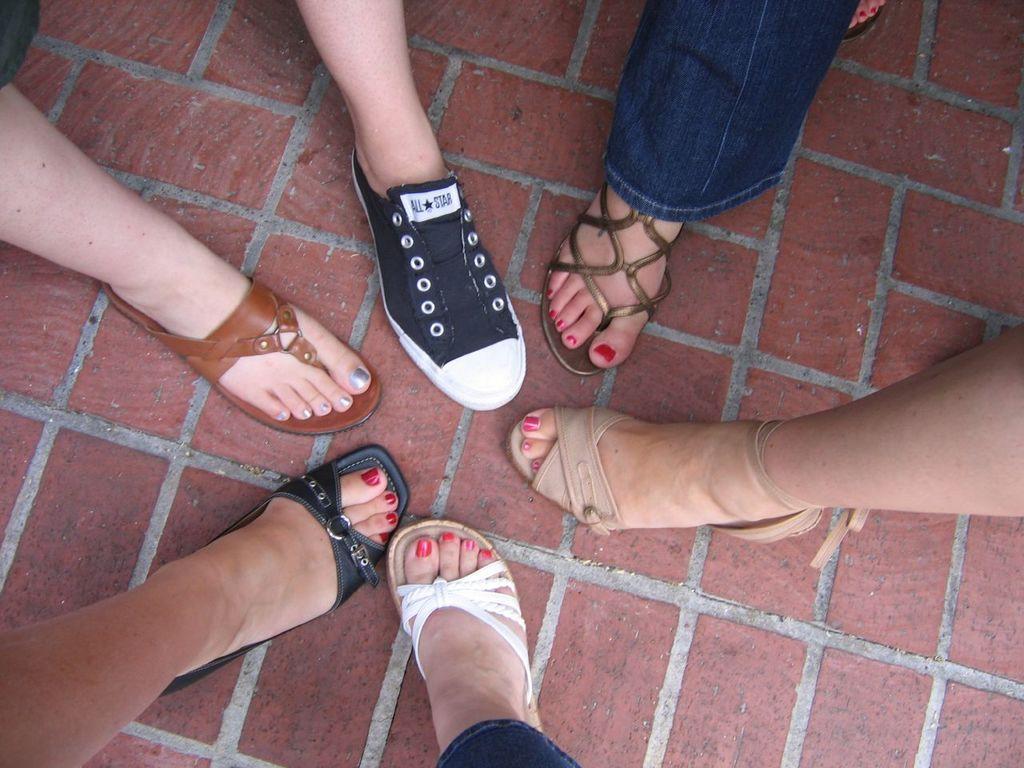Please provide a concise description of this image. In the image there are legs of different people and their footwear is also unique. 